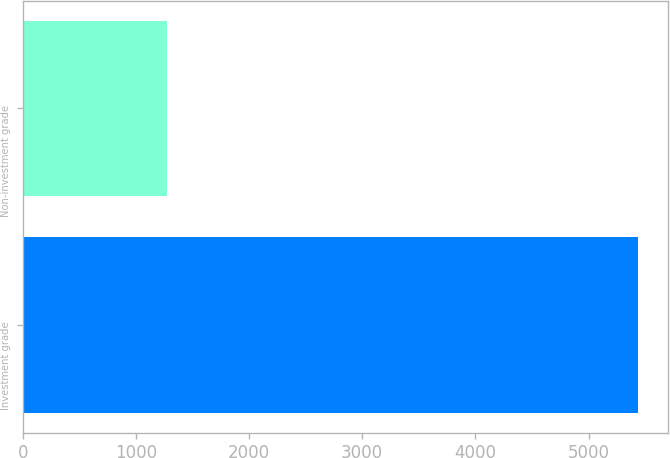Convert chart. <chart><loc_0><loc_0><loc_500><loc_500><bar_chart><fcel>Investment grade<fcel>Non-investment grade<nl><fcel>5433<fcel>1278<nl></chart> 